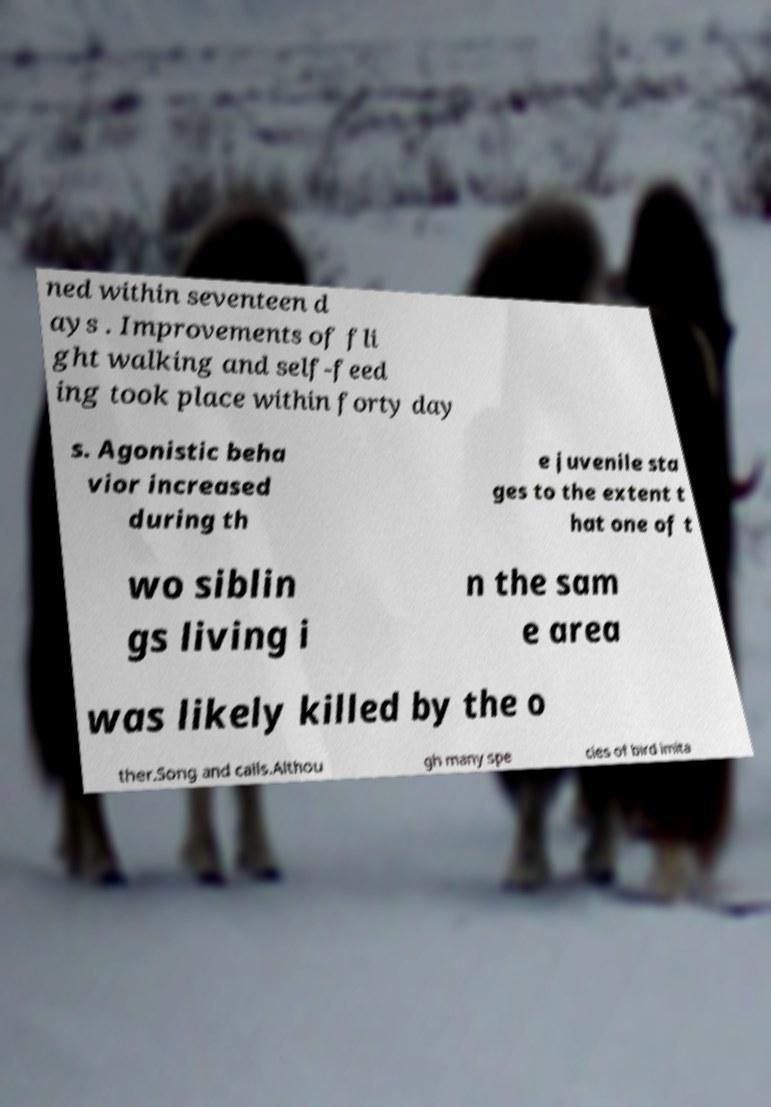There's text embedded in this image that I need extracted. Can you transcribe it verbatim? ned within seventeen d ays . Improvements of fli ght walking and self-feed ing took place within forty day s. Agonistic beha vior increased during th e juvenile sta ges to the extent t hat one of t wo siblin gs living i n the sam e area was likely killed by the o ther.Song and calls.Althou gh many spe cies of bird imita 